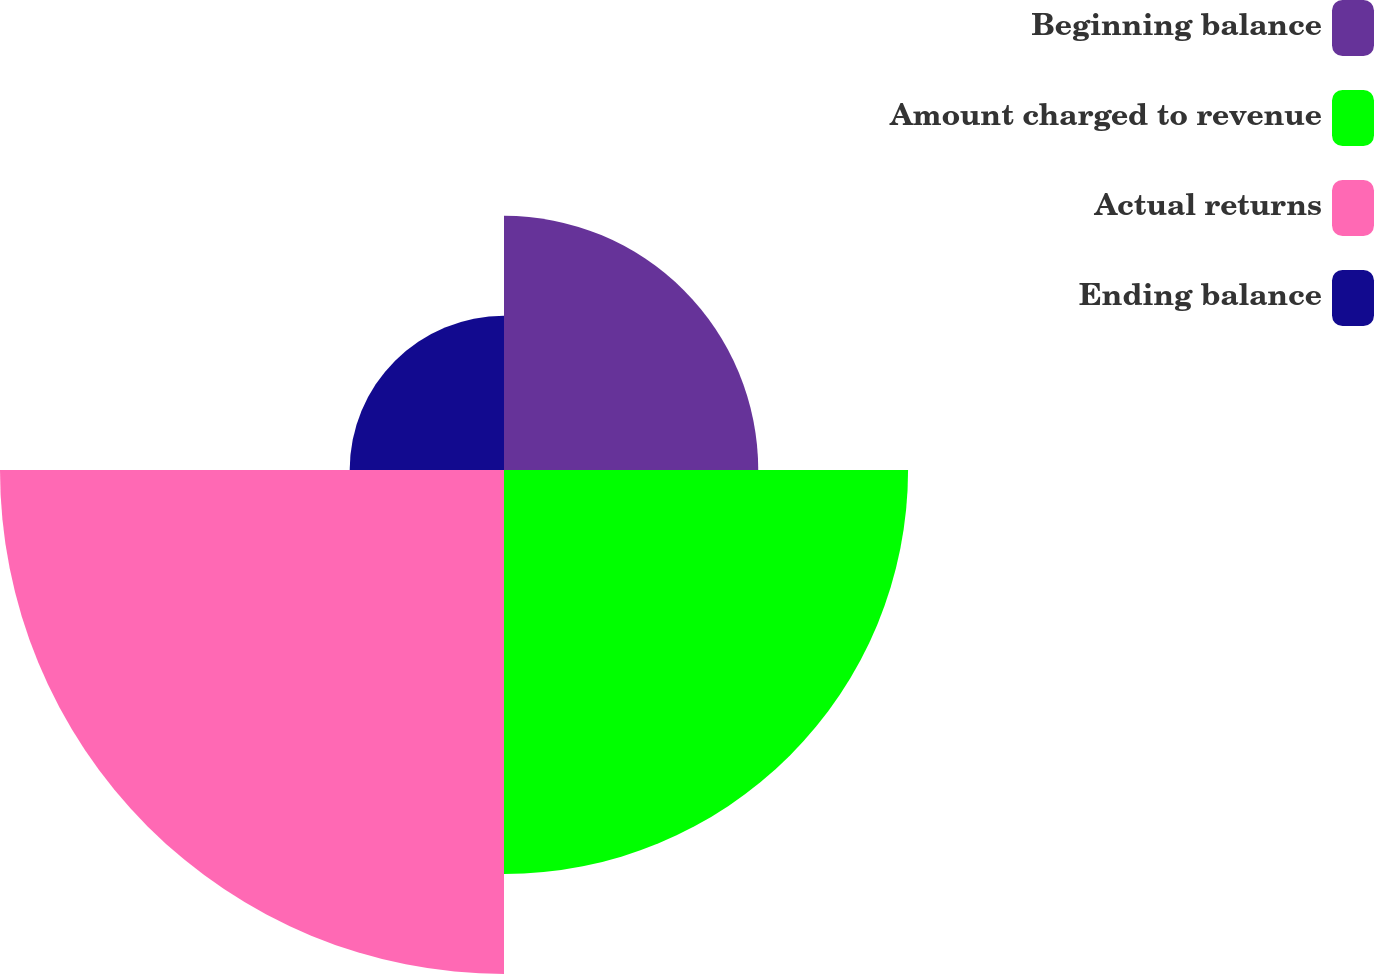Convert chart. <chart><loc_0><loc_0><loc_500><loc_500><pie_chart><fcel>Beginning balance<fcel>Amount charged to revenue<fcel>Actual returns<fcel>Ending balance<nl><fcel>19.31%<fcel>30.69%<fcel>38.28%<fcel>11.72%<nl></chart> 